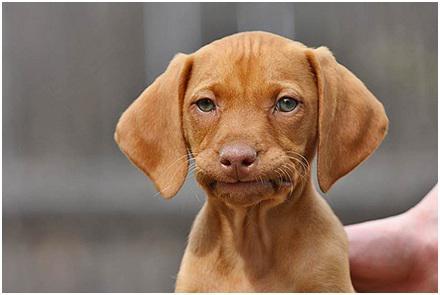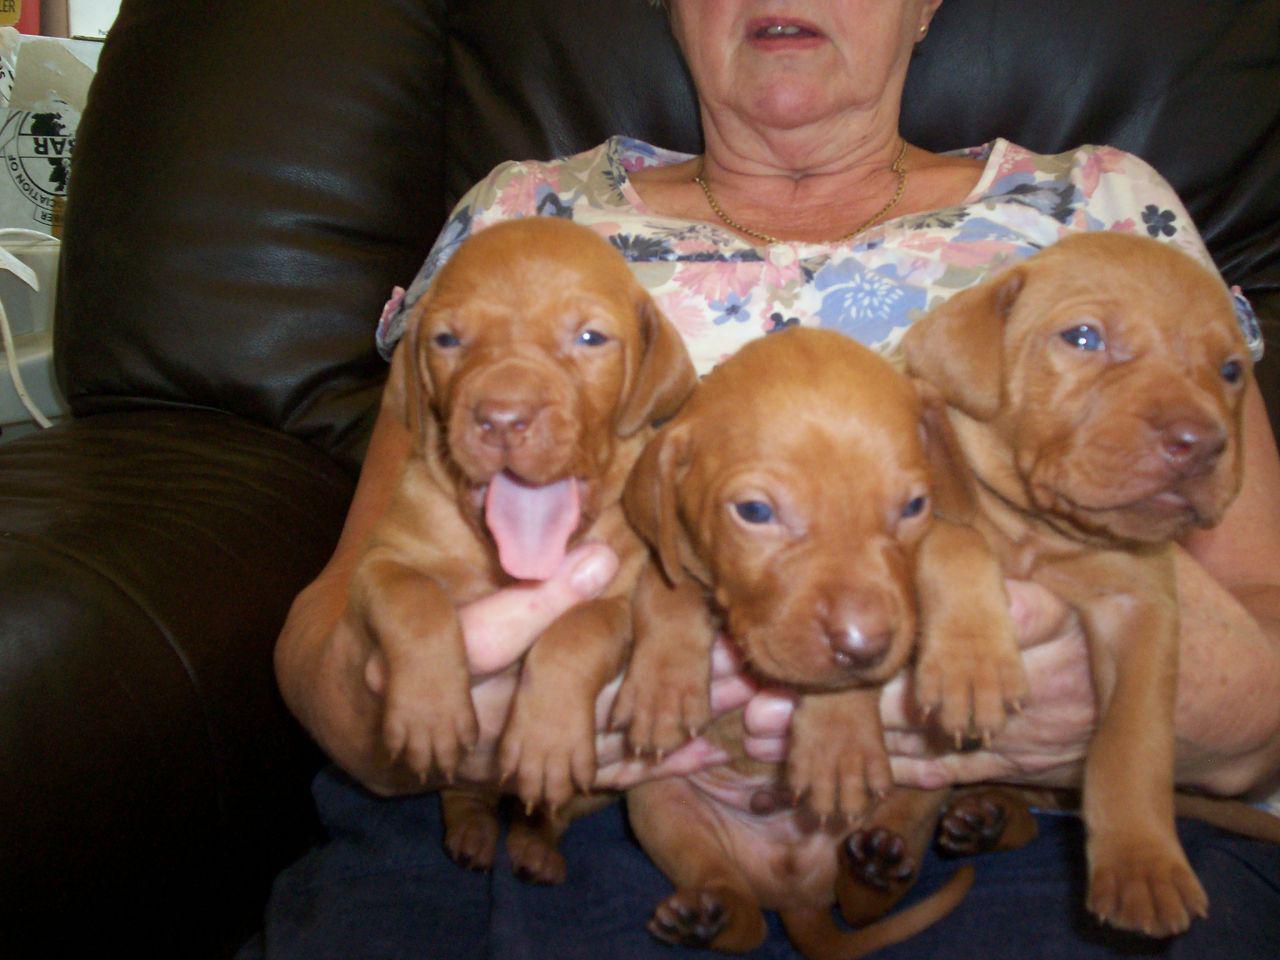The first image is the image on the left, the second image is the image on the right. Analyze the images presented: Is the assertion "Each image contains one red-orange dog, each dog has short hair and a closed mouth, and one image shows a dog with an upright head facing forward." valid? Answer yes or no. No. The first image is the image on the left, the second image is the image on the right. Evaluate the accuracy of this statement regarding the images: "There are two dogs.". Is it true? Answer yes or no. No. 